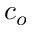Convert formula to latex. <formula><loc_0><loc_0><loc_500><loc_500>c _ { o }</formula> 